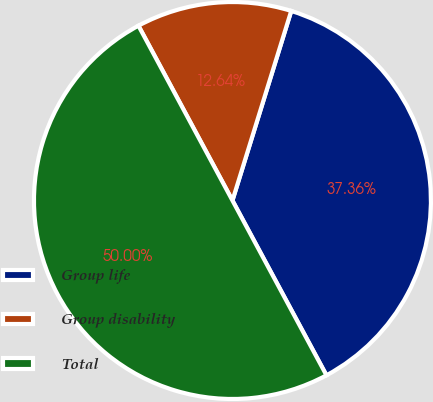Convert chart. <chart><loc_0><loc_0><loc_500><loc_500><pie_chart><fcel>Group life<fcel>Group disability<fcel>Total<nl><fcel>37.36%<fcel>12.64%<fcel>50.0%<nl></chart> 